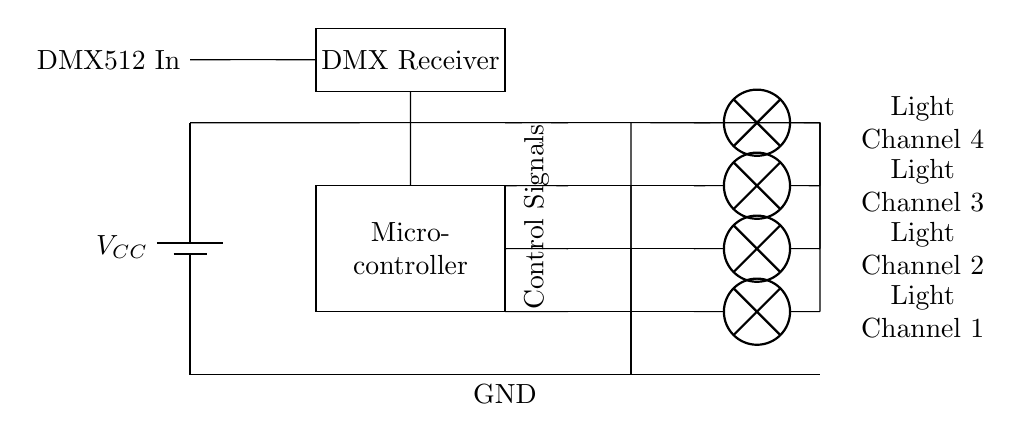What type of circuit is this? This is a digital lighting control circuit, indicated by the presence of a microcontroller and DMX512 input for controlling lighting channels.
Answer: digital lighting control circuit What does DMX512 stand for? DMX512 stands for Digital Multiplex, a communication protocol used for controlling lighting and effects in theater and stage productions, as shown in the input label.
Answer: Digital Multiplex How many output channels are present in the circuit? There are four output channels, as represented by the four light channels connected to the microcontroller through PNP transistors.
Answer: four What component controls the lights in this circuit? The microcontroller controls the lights, as it processes signals from the DMX512 input and sends control signals to the output channels.
Answer: microcontroller What type of device is used to turn on the lights? PNP transistors are used to turn on the lights, as indicated by their placement between the microcontroller outputs and the lamps.
Answer: PNP transistors What is the purpose of the battery in this circuit? The battery provides the necessary voltage supply for the circuit, ensuring all components, including the microcontroller and lamps, are powered.
Answer: voltage supply What is the role of the ground connections? The ground connections provide a common reference point for voltage levels in the circuit, ensuring all components work correctly with a stable reference.
Answer: reference point 